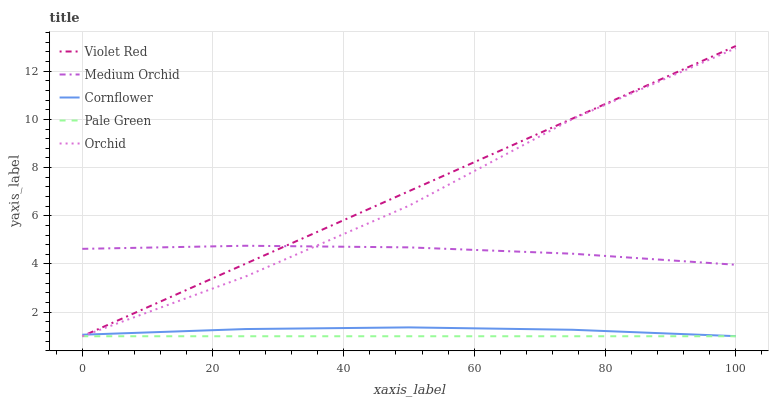Does Pale Green have the minimum area under the curve?
Answer yes or no. Yes. Does Violet Red have the maximum area under the curve?
Answer yes or no. Yes. Does Cornflower have the minimum area under the curve?
Answer yes or no. No. Does Cornflower have the maximum area under the curve?
Answer yes or no. No. Is Violet Red the smoothest?
Answer yes or no. Yes. Is Orchid the roughest?
Answer yes or no. Yes. Is Cornflower the smoothest?
Answer yes or no. No. Is Cornflower the roughest?
Answer yes or no. No. Does Orchid have the lowest value?
Answer yes or no. Yes. Does Cornflower have the lowest value?
Answer yes or no. No. Does Violet Red have the highest value?
Answer yes or no. Yes. Does Cornflower have the highest value?
Answer yes or no. No. Is Pale Green less than Medium Orchid?
Answer yes or no. Yes. Is Medium Orchid greater than Cornflower?
Answer yes or no. Yes. Does Orchid intersect Violet Red?
Answer yes or no. Yes. Is Orchid less than Violet Red?
Answer yes or no. No. Is Orchid greater than Violet Red?
Answer yes or no. No. Does Pale Green intersect Medium Orchid?
Answer yes or no. No. 